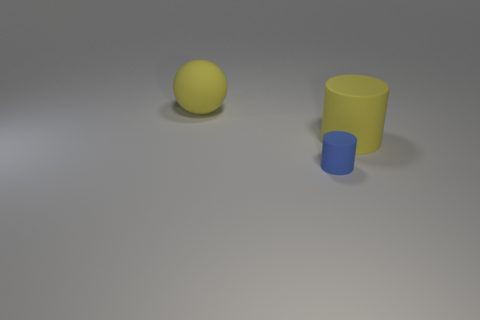What objects can be seen in the image and what are their colors? The image showcases two objects: a large yellow ball and a small cylinder, with the latter appearing in a matte cyan or blue color. 